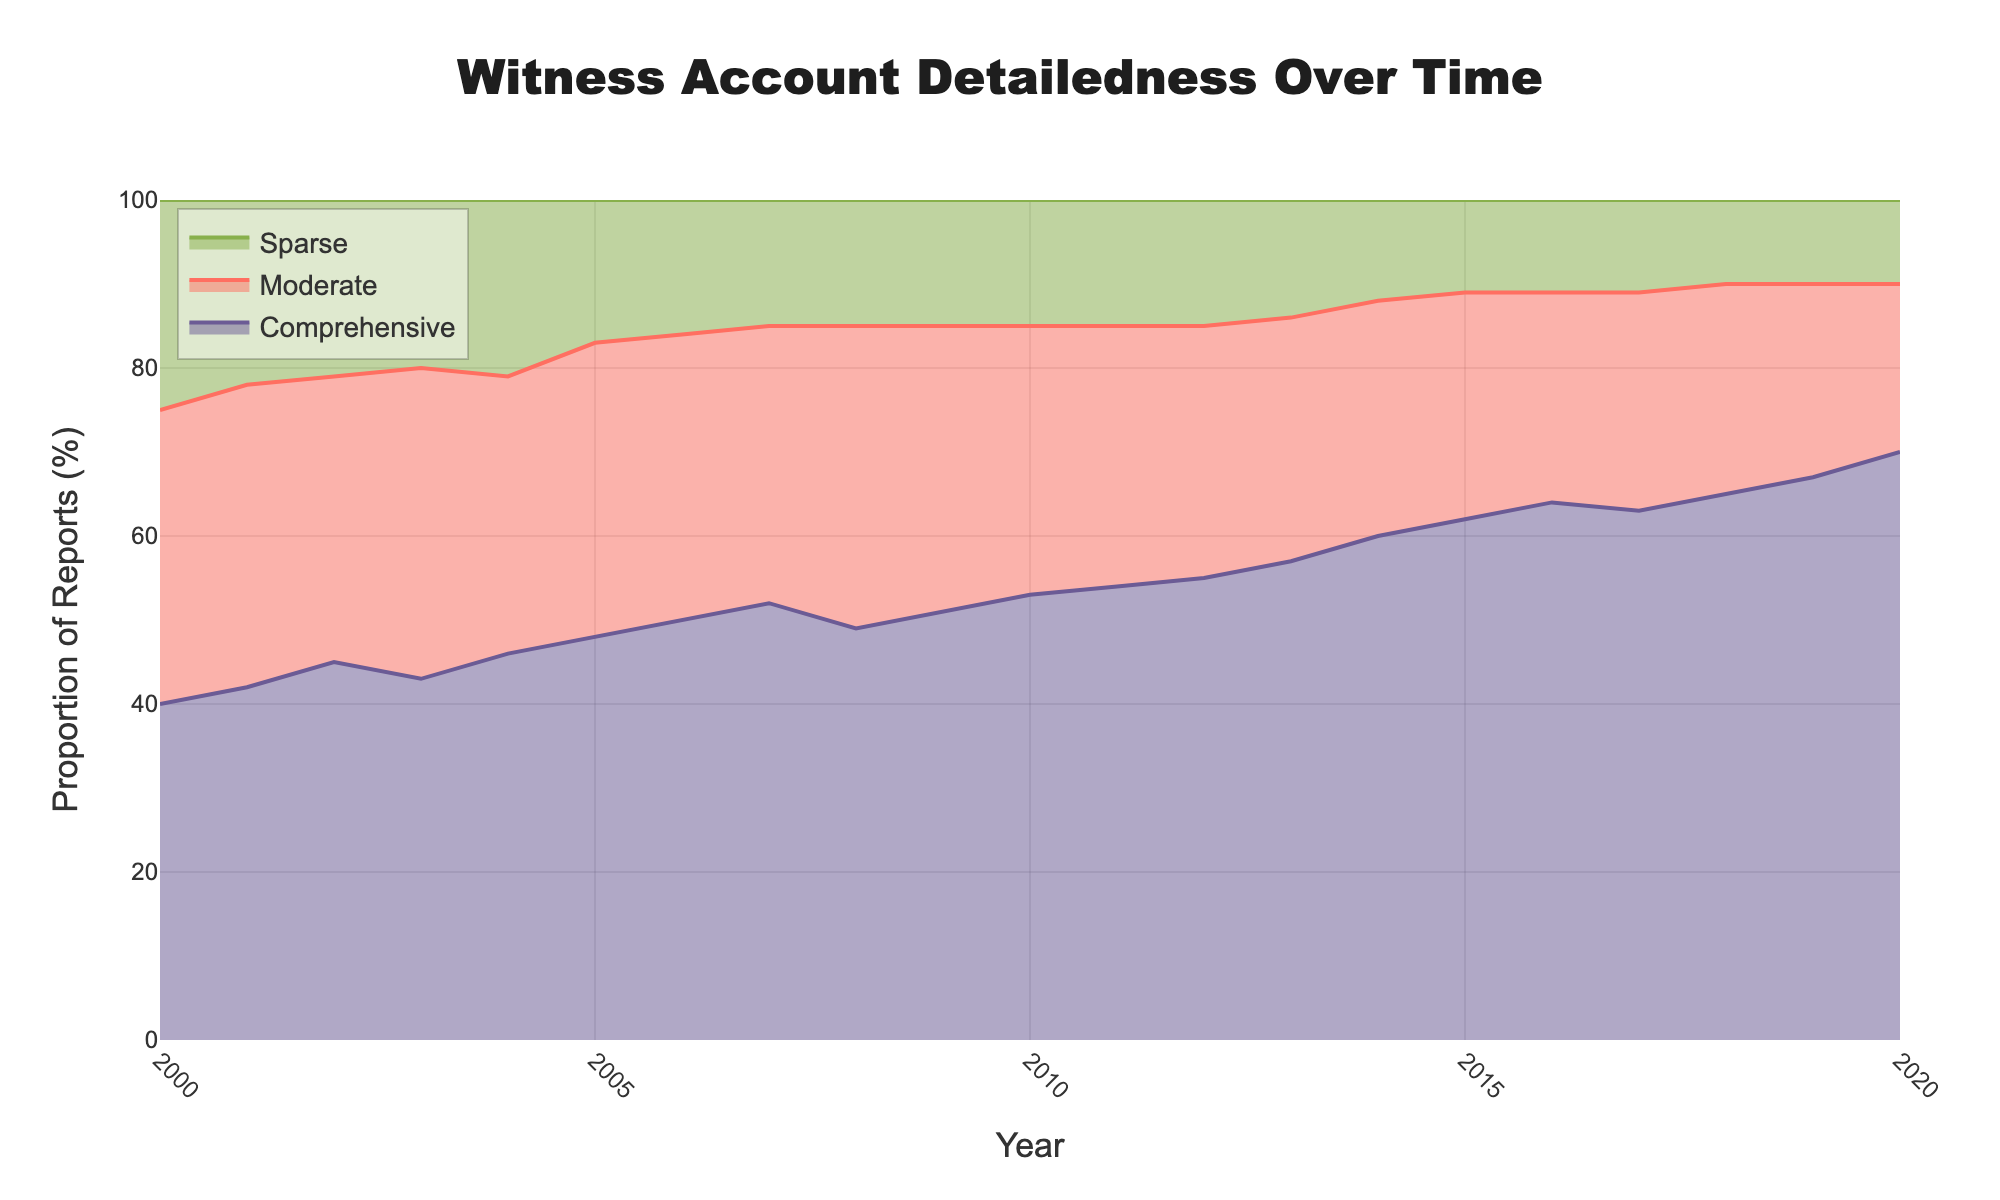what's the title of the chart? The title is located at the top-center of the chart. It provides a summary description of the data visualized in the figure.
Answer: "Witness Account Detailedness Over Time" what are the proportions of comprehensive reports in the year 2010? To find this, locate the year 2010 on the x-axis and observe the y-value for 'Comprehensive' reports.
Answer: 53% how do the proportions of comprehensive and sparse reports in 2020 compare? You need to find the proportions of both 'Comprehensive' and 'Sparse' reports in 2020 from the chart and compare them. Proportions of 'Comprehensive' are higher than those of 'Sparse' reports.
Answer: Comprehensive: 70%, Sparse: 10% which year has the highest proportion of comprehensive reports? By examining the proportions for 'Comprehensive' reports over the entire time range, you can identify the highest point.
Answer: 2020 what’s the trend for moderate reports from 2000 to 2020? Observe the line for 'Moderate' reports from the year 2000 to 2020 to determine the trend. The trend shows that the proportion of 'Moderate' reports generally declines over the period.
Answer: Decreasing what is the total proportion of comprehensive and moderate reports in 2015? Find the values for 'Comprehensive' and 'Moderate' reports in 2015 and sum them up: 62% (Comprehensive) + 27% (Moderate) = 89%.
Answer: 89% how does the distribution of sparse reports change from 2000 to 2020? Observe the line for 'Sparse' reports from 2000 to 2020 to see the changes. 'Sparse' reports proportion decreases gradually.
Answer: Decreasing in which years do comprehensive reports exceed 60%? Scan the chart to find years where the 'Comprehensive' proportion is more than the 60% mark.
Answer: 2014, 2015, 2016, 2018, 2019, 2020 what’s the average proportion of moderate reports over the entire period? Add the proportions of 'Moderate' reports for all years and divide by the number of years (21).
Answer: (35+36+34+37+33+35+34+33+36+34+32+31+30+29+28+27+25+26+25+23+20)/21 = 31.4% what trend can you observe for comprehensive reports over the years? Observe the 'Comprehensive' reports line from 2000 to 2020. The line shows a clear upward trend indicating an increase over the period.
Answer: Increasing 